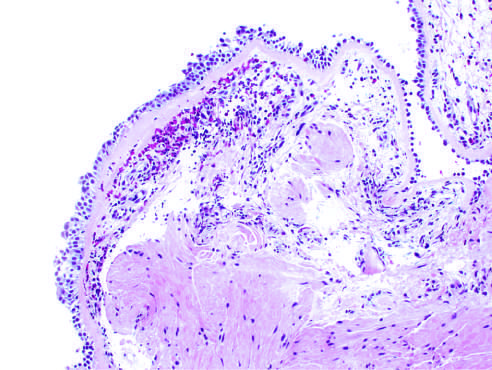what shows sub-basement membrane fibrosis, eosinophilic inflammation, and smooth muscle hyperplasia?
Answer the question using a single word or phrase. The bronchial biopsy specimen 